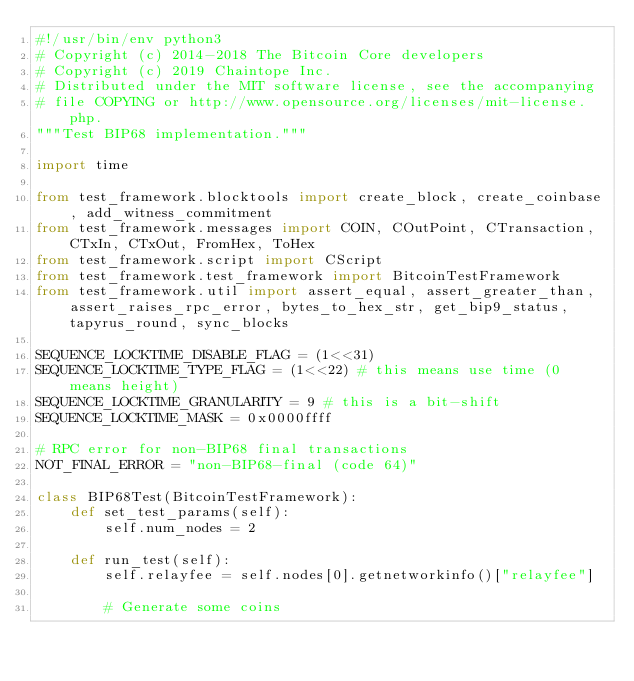Convert code to text. <code><loc_0><loc_0><loc_500><loc_500><_Python_>#!/usr/bin/env python3
# Copyright (c) 2014-2018 The Bitcoin Core developers
# Copyright (c) 2019 Chaintope Inc.
# Distributed under the MIT software license, see the accompanying
# file COPYING or http://www.opensource.org/licenses/mit-license.php.
"""Test BIP68 implementation."""

import time

from test_framework.blocktools import create_block, create_coinbase, add_witness_commitment
from test_framework.messages import COIN, COutPoint, CTransaction, CTxIn, CTxOut, FromHex, ToHex
from test_framework.script import CScript
from test_framework.test_framework import BitcoinTestFramework
from test_framework.util import assert_equal, assert_greater_than, assert_raises_rpc_error, bytes_to_hex_str, get_bip9_status, tapyrus_round, sync_blocks

SEQUENCE_LOCKTIME_DISABLE_FLAG = (1<<31)
SEQUENCE_LOCKTIME_TYPE_FLAG = (1<<22) # this means use time (0 means height)
SEQUENCE_LOCKTIME_GRANULARITY = 9 # this is a bit-shift
SEQUENCE_LOCKTIME_MASK = 0x0000ffff

# RPC error for non-BIP68 final transactions
NOT_FINAL_ERROR = "non-BIP68-final (code 64)"

class BIP68Test(BitcoinTestFramework):
    def set_test_params(self):
        self.num_nodes = 2

    def run_test(self):
        self.relayfee = self.nodes[0].getnetworkinfo()["relayfee"]

        # Generate some coins</code> 